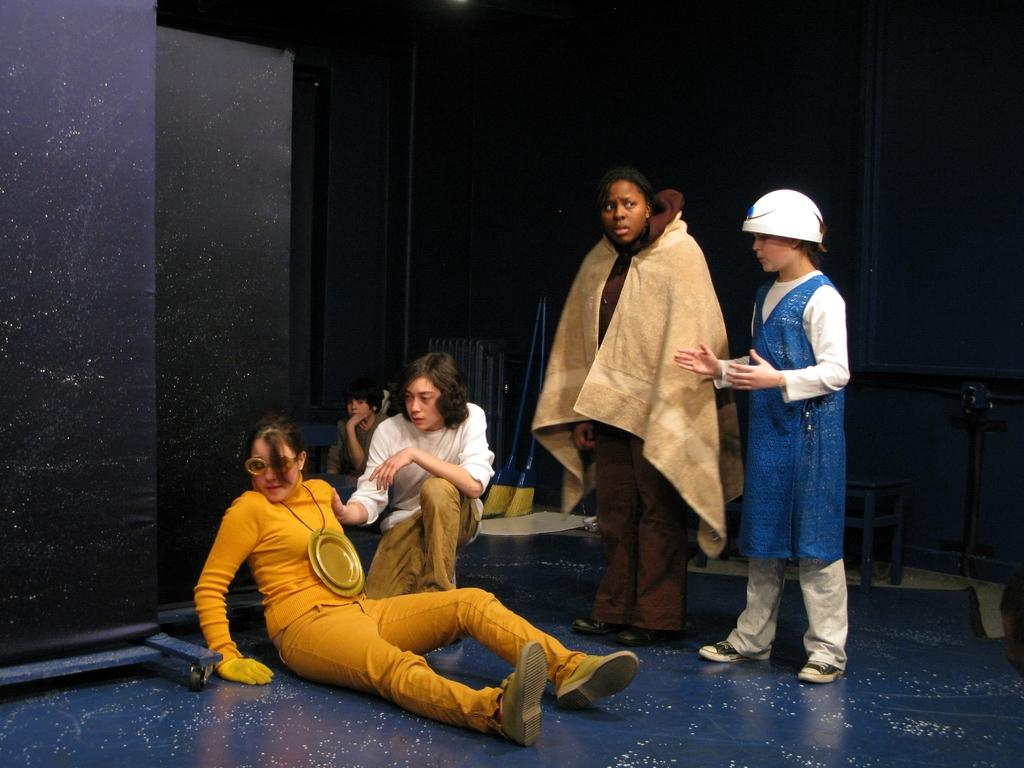How many persons are in the image? There are persons in the image. What is the position of one of the persons in the image? A person is sitting on the floor. What type of furniture is present in the image? There is a stool and a chair in the image. What objects are used for painting or art in the image? There are brushes in the image. What can be seen in the background of the image? There is a wall in the background of the image. What type of garden can be seen in the image? There is no garden present in the image. What day of the week is it in the image? The day of the week cannot be determined from the image. 